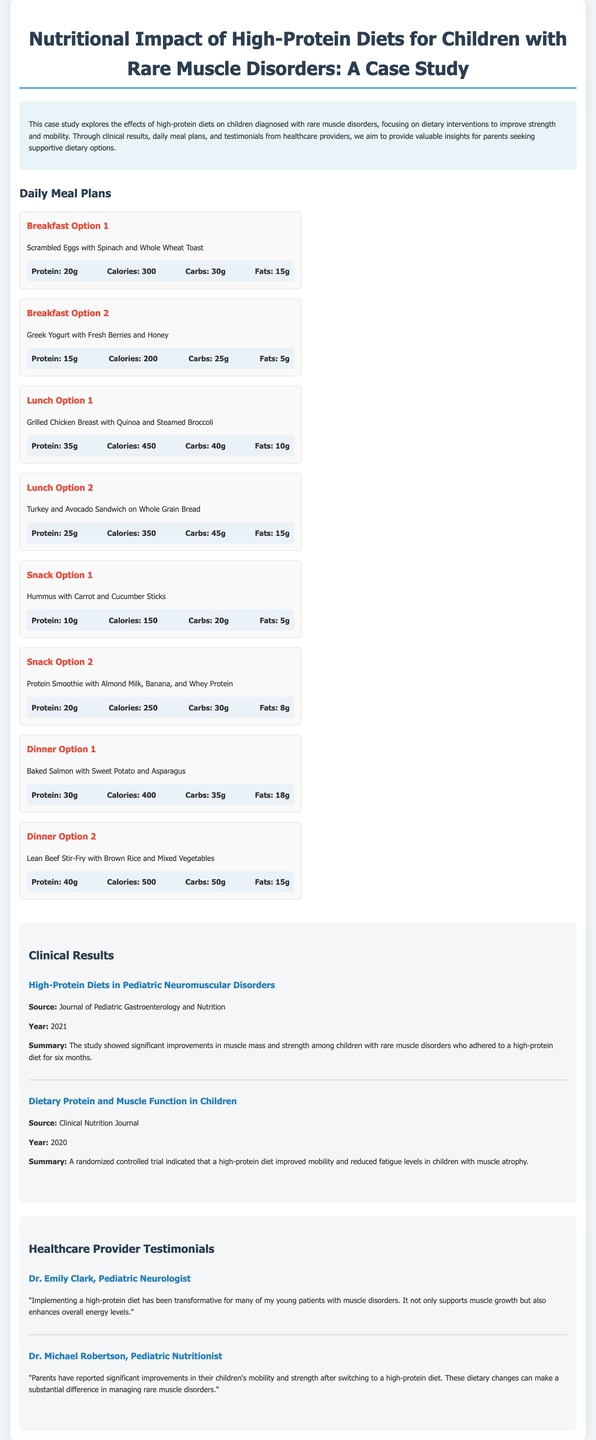What is the main objective of the case study? The case study aims to explore the effects of high-protein diets on children diagnosed with rare muscle disorders, focusing on dietary interventions to improve strength and mobility.
Answer: Improve strength and mobility How many breakfast options are provided in the meal plans? The document lists a total of four breakfast options for dietary recommendations.
Answer: Four What is the total protein content in Dinner Option 1? The total protein for Dinner Option 1 (Baked Salmon with Sweet Potato and Asparagus) is stated as 30 grams.
Answer: 30g What improvement was observed in a study published in the Journal of Pediatric Gastroenterology and Nutrition in 2021? The study showed significant improvements in muscle mass and strength among children with rare muscle disorders who adhered to a high-protein diet.
Answer: Muscle mass and strength Who reported significant improvements in children's mobility and strength after dietary changes? Dr. Michael Robertson, a Pediatric Nutritionist, noted improvements in children's mobility and strength in his testimony.
Answer: Dr. Michael Robertson What type of diet was associated with reduced fatigue levels in children with muscle atrophy? A high-protein diet was linked to improved mobility and reduced fatigue levels in children with muscle atrophy, as per the clinical nutrition study.
Answer: High-protein diet What year was the randomized controlled trial published that indicated a high-protein diet's effectiveness? The randomized controlled trial indicating the effectiveness was published in the year 2020.
Answer: 2020 What food item is featured in Snack Option 2? Snack Option 2 features a Protein Smoothie with Almond Milk, Banana, and Whey Protein.
Answer: Protein Smoothie 